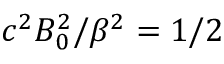<formula> <loc_0><loc_0><loc_500><loc_500>c ^ { 2 } B _ { 0 } ^ { 2 } / \beta ^ { 2 } = 1 / 2</formula> 